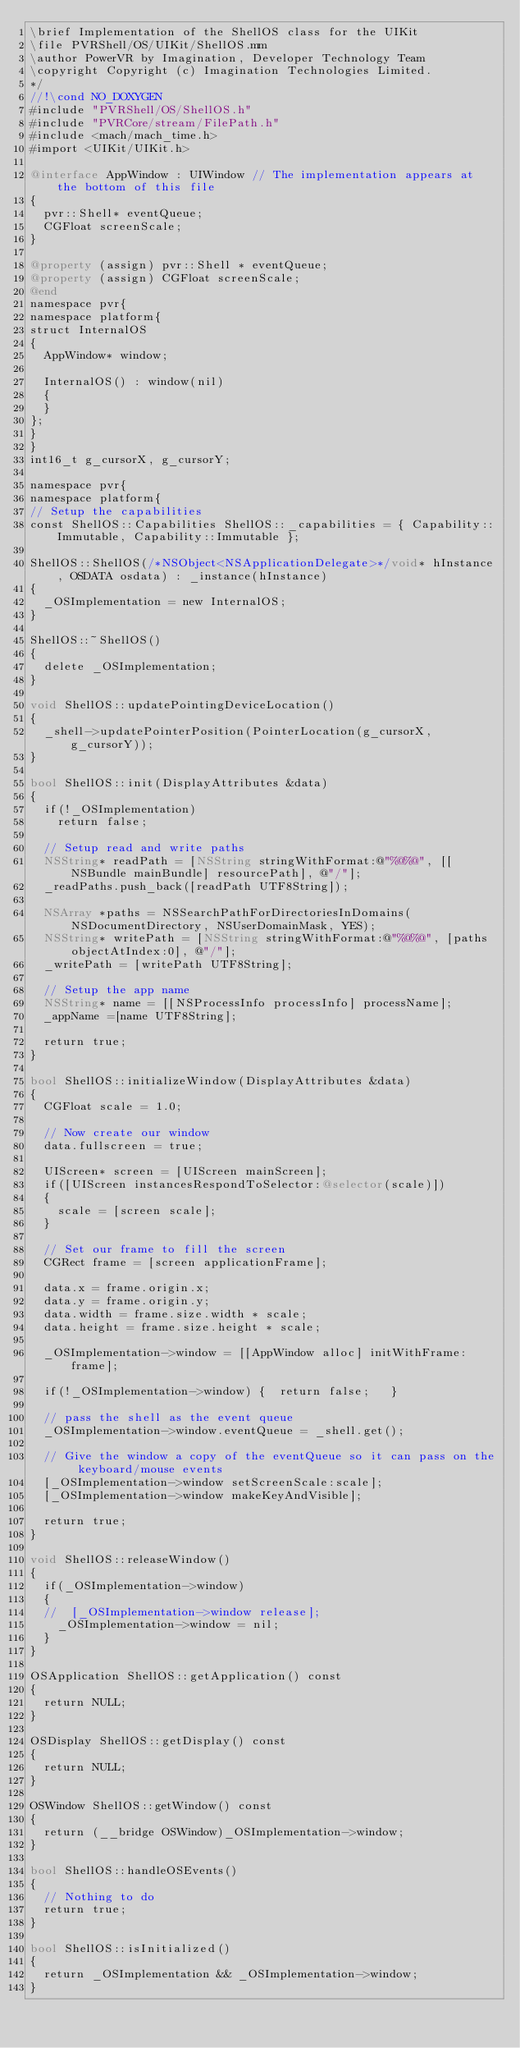Convert code to text. <code><loc_0><loc_0><loc_500><loc_500><_ObjectiveC_>\brief Implementation of the ShellOS class for the UIKit
\file PVRShell/OS/UIKit/ShellOS.mm
\author PowerVR by Imagination, Developer Technology Team
\copyright Copyright (c) Imagination Technologies Limited.
*/
//!\cond NO_DOXYGEN
#include "PVRShell/OS/ShellOS.h"
#include "PVRCore/stream/FilePath.h"
#include <mach/mach_time.h>
#import <UIKit/UIKit.h>

@interface AppWindow : UIWindow // The implementation appears at the bottom of this file
{
	pvr::Shell* eventQueue;
	CGFloat screenScale;
}

@property (assign) pvr::Shell * eventQueue;
@property (assign) CGFloat screenScale;
@end
namespace pvr{
namespace platform{
struct InternalOS
{
	AppWindow* window;

	InternalOS() : window(nil)
	{
	}
};
}
}
int16_t g_cursorX, g_cursorY;

namespace pvr{
namespace platform{
// Setup the capabilities
const ShellOS::Capabilities ShellOS::_capabilities = { Capability::Immutable, Capability::Immutable };

ShellOS::ShellOS(/*NSObject<NSApplicationDelegate>*/void* hInstance, OSDATA osdata) : _instance(hInstance)
{
	_OSImplementation = new InternalOS;
}

ShellOS::~ShellOS()
{
	delete _OSImplementation;
}

void ShellOS::updatePointingDeviceLocation()
{
	_shell->updatePointerPosition(PointerLocation(g_cursorX, g_cursorY));
}

bool ShellOS::init(DisplayAttributes &data)
{
	if(!_OSImplementation)
		return false;

	// Setup read and write paths
	NSString* readPath = [NSString stringWithFormat:@"%@%@", [[NSBundle mainBundle] resourcePath], @"/"];
	_readPaths.push_back([readPath UTF8String]);

	NSArray *paths = NSSearchPathForDirectoriesInDomains(NSDocumentDirectory, NSUserDomainMask, YES);
	NSString* writePath = [NSString stringWithFormat:@"%@%@", [paths objectAtIndex:0], @"/"];
	_writePath = [writePath UTF8String];
	
	// Setup the app name
	NSString* name = [[NSProcessInfo processInfo] processName];
	_appName =[name UTF8String];
	
	return true;
}

bool ShellOS::initializeWindow(DisplayAttributes &data)
{
	CGFloat scale = 1.0;
	
	// Now create our window
	data.fullscreen = true;
 
	UIScreen* screen = [UIScreen mainScreen];
	if([UIScreen instancesRespondToSelector:@selector(scale)])
	{
		scale = [screen scale];
	}
	
	// Set our frame to fill the screen
	CGRect frame = [screen applicationFrame];

	data.x = frame.origin.x;
	data.y = frame.origin.y;
	data.width = frame.size.width * scale;
	data.height = frame.size.height * scale;

	_OSImplementation->window = [[AppWindow alloc] initWithFrame:frame];
	
	if(!_OSImplementation->window) {  return false;   }
	
	// pass the shell as the event queue
	_OSImplementation->window.eventQueue = _shell.get();
	
	// Give the window a copy of the eventQueue so it can pass on the keyboard/mouse events
	[_OSImplementation->window setScreenScale:scale];
	[_OSImplementation->window makeKeyAndVisible];
	
	return true;
}

void ShellOS::releaseWindow()
{
	if(_OSImplementation->window)
	{
	//	[_OSImplementation->window release];
		_OSImplementation->window = nil;
	}
}

OSApplication ShellOS::getApplication() const
{
	return NULL;
}

OSDisplay ShellOS::getDisplay() const
{
	return NULL;
}

OSWindow ShellOS::getWindow() const
{
	return (__bridge OSWindow)_OSImplementation->window;
}

bool ShellOS::handleOSEvents()
{
	// Nothing to do
	return true;
}

bool ShellOS::isInitialized()
{
	return _OSImplementation && _OSImplementation->window;
}
</code> 